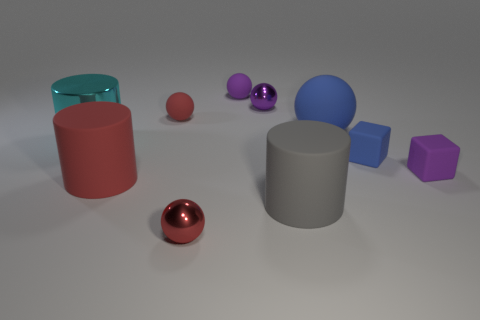How many purple spheres must be subtracted to get 1 purple spheres? 1 Subtract all blue balls. How many balls are left? 4 Subtract all large blue spheres. How many spheres are left? 4 Subtract all yellow balls. Subtract all purple cylinders. How many balls are left? 5 Subtract all cylinders. How many objects are left? 7 Add 8 tiny blue cylinders. How many tiny blue cylinders exist? 8 Subtract 0 green cubes. How many objects are left? 10 Subtract all red balls. Subtract all tiny blue rubber objects. How many objects are left? 7 Add 5 purple rubber blocks. How many purple rubber blocks are left? 6 